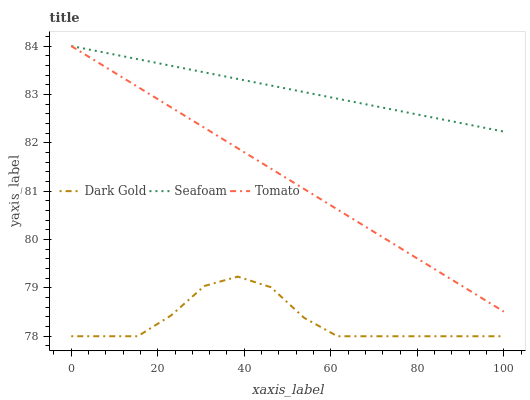Does Seafoam have the minimum area under the curve?
Answer yes or no. No. Does Dark Gold have the maximum area under the curve?
Answer yes or no. No. Is Seafoam the smoothest?
Answer yes or no. No. Is Seafoam the roughest?
Answer yes or no. No. Does Seafoam have the lowest value?
Answer yes or no. No. Does Dark Gold have the highest value?
Answer yes or no. No. Is Dark Gold less than Seafoam?
Answer yes or no. Yes. Is Tomato greater than Dark Gold?
Answer yes or no. Yes. Does Dark Gold intersect Seafoam?
Answer yes or no. No. 